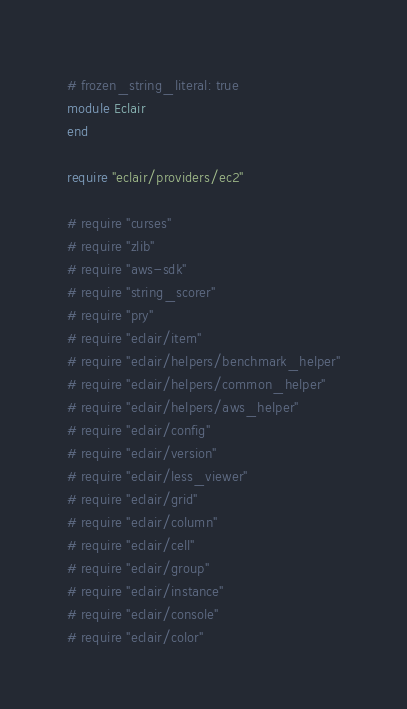<code> <loc_0><loc_0><loc_500><loc_500><_Ruby_># frozen_string_literal: true
module Eclair
end

require "eclair/providers/ec2"

# require "curses"
# require "zlib"
# require "aws-sdk"
# require "string_scorer"
# require "pry"
# require "eclair/item"
# require "eclair/helpers/benchmark_helper"
# require "eclair/helpers/common_helper"
# require "eclair/helpers/aws_helper"
# require "eclair/config"
# require "eclair/version"
# require "eclair/less_viewer"
# require "eclair/grid"
# require "eclair/column"
# require "eclair/cell"
# require "eclair/group"
# require "eclair/instance"
# require "eclair/console"
# require "eclair/color"
</code> 